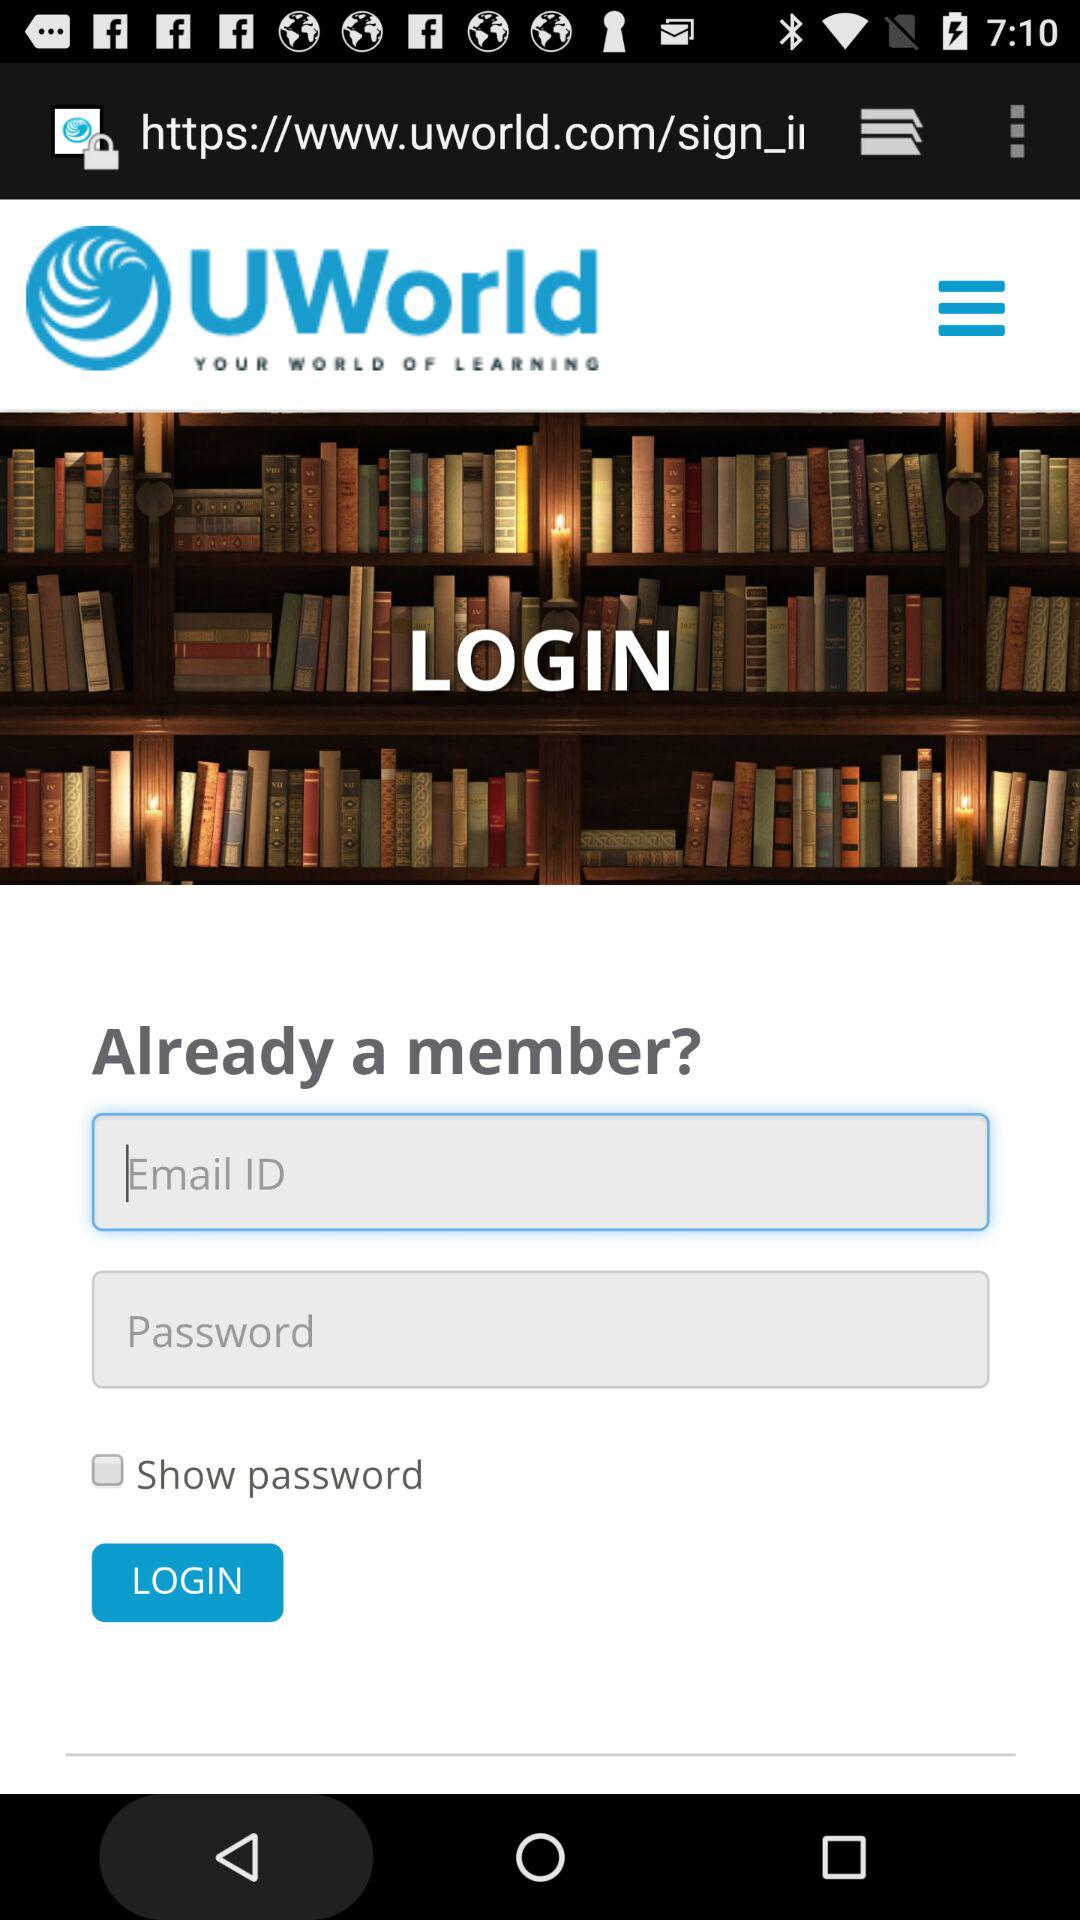How many more text inputs are there than checkboxes?
Answer the question using a single word or phrase. 1 